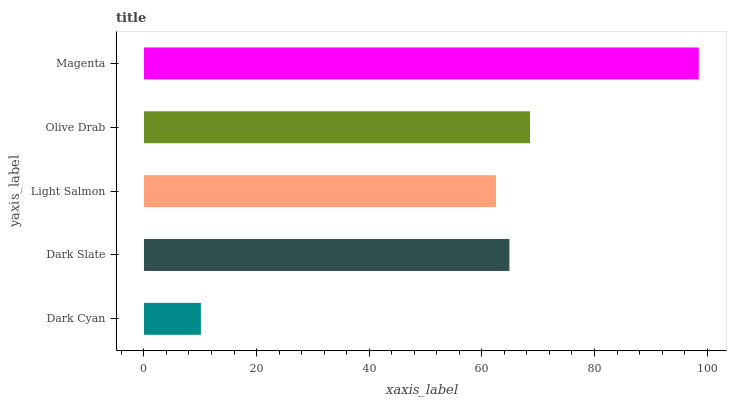Is Dark Cyan the minimum?
Answer yes or no. Yes. Is Magenta the maximum?
Answer yes or no. Yes. Is Dark Slate the minimum?
Answer yes or no. No. Is Dark Slate the maximum?
Answer yes or no. No. Is Dark Slate greater than Dark Cyan?
Answer yes or no. Yes. Is Dark Cyan less than Dark Slate?
Answer yes or no. Yes. Is Dark Cyan greater than Dark Slate?
Answer yes or no. No. Is Dark Slate less than Dark Cyan?
Answer yes or no. No. Is Dark Slate the high median?
Answer yes or no. Yes. Is Dark Slate the low median?
Answer yes or no. Yes. Is Dark Cyan the high median?
Answer yes or no. No. Is Olive Drab the low median?
Answer yes or no. No. 